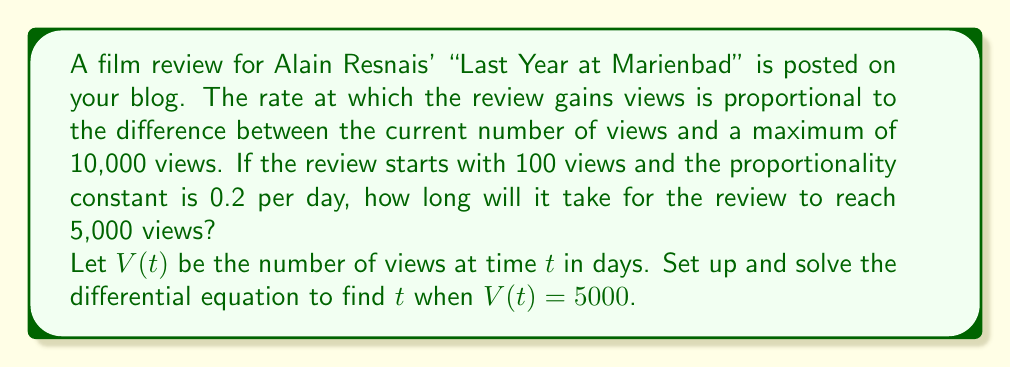Can you solve this math problem? Let's approach this step-by-step:

1) The rate of change of views is proportional to the difference between the maximum views and current views. This can be expressed as:

   $$\frac{dV}{dt} = k(V_{max} - V)$$

   where $k$ is the proportionality constant.

2) We're given:
   - $k = 0.2$ per day
   - $V_{max} = 10000$ views
   - $V(0) = 100$ views (initial condition)
   - We need to find $t$ when $V(t) = 5000$ views

3) Substituting these values, our differential equation becomes:

   $$\frac{dV}{dt} = 0.2(10000 - V)$$

4) This is a separable differential equation. Let's separate variables:

   $$\frac{dV}{10000 - V} = 0.2dt$$

5) Integrating both sides:

   $$-\ln|10000 - V| = 0.2t + C$$

6) Using the initial condition $V(0) = 100$, we can find $C$:

   $$-\ln(10000 - 100) = C$$
   $$C = -\ln(9900)$$

7) Substituting back:

   $$-\ln|10000 - V| = 0.2t - \ln(9900)$$

8) Solving for $V$:

   $$V = 10000 - 9900e^{-0.2t}$$

9) Now, we want to find $t$ when $V = 5000$:

   $$5000 = 10000 - 9900e^{-0.2t}$$

10) Solving for $t$:

    $$9900e^{-0.2t} = 5000$$
    $$e^{-0.2t} = \frac{5000}{9900} \approx 0.5051$$
    $$-0.2t = \ln(0.5051)$$
    $$t = -\frac{\ln(0.5051)}{0.2} \approx 3.4 \text{ days}$$

Therefore, it will take approximately 3.4 days for the review to reach 5,000 views.
Answer: $t \approx 3.4$ days 